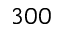Convert formula to latex. <formula><loc_0><loc_0><loc_500><loc_500>3 0 0</formula> 